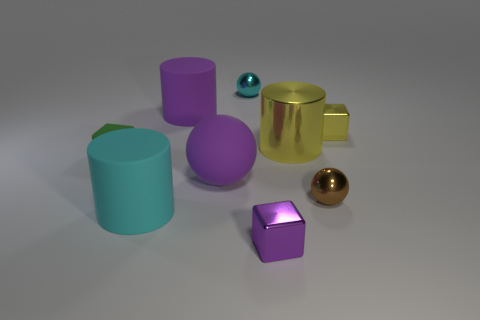There is a purple shiny thing; what shape is it?
Provide a short and direct response. Cube. What number of things are either shiny cylinders that are behind the tiny purple metal block or large metallic cylinders?
Provide a succinct answer. 1. What number of other objects are the same color as the large shiny cylinder?
Your response must be concise. 1. There is a big metal cylinder; does it have the same color as the sphere on the right side of the tiny cyan shiny ball?
Make the answer very short. No. There is another large rubber thing that is the same shape as the cyan rubber thing; what color is it?
Your answer should be compact. Purple. Is the material of the yellow cylinder the same as the big purple thing in front of the rubber block?
Ensure brevity in your answer.  No. The rubber block has what color?
Offer a very short reply. Green. The big rubber cylinder left of the large rubber cylinder to the right of the cylinder that is in front of the large purple ball is what color?
Make the answer very short. Cyan. There is a small yellow thing; is its shape the same as the purple object in front of the large purple sphere?
Offer a very short reply. Yes. The object that is behind the yellow metallic cylinder and on the left side of the cyan sphere is what color?
Keep it short and to the point. Purple. 